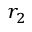Convert formula to latex. <formula><loc_0><loc_0><loc_500><loc_500>r _ { 2 }</formula> 